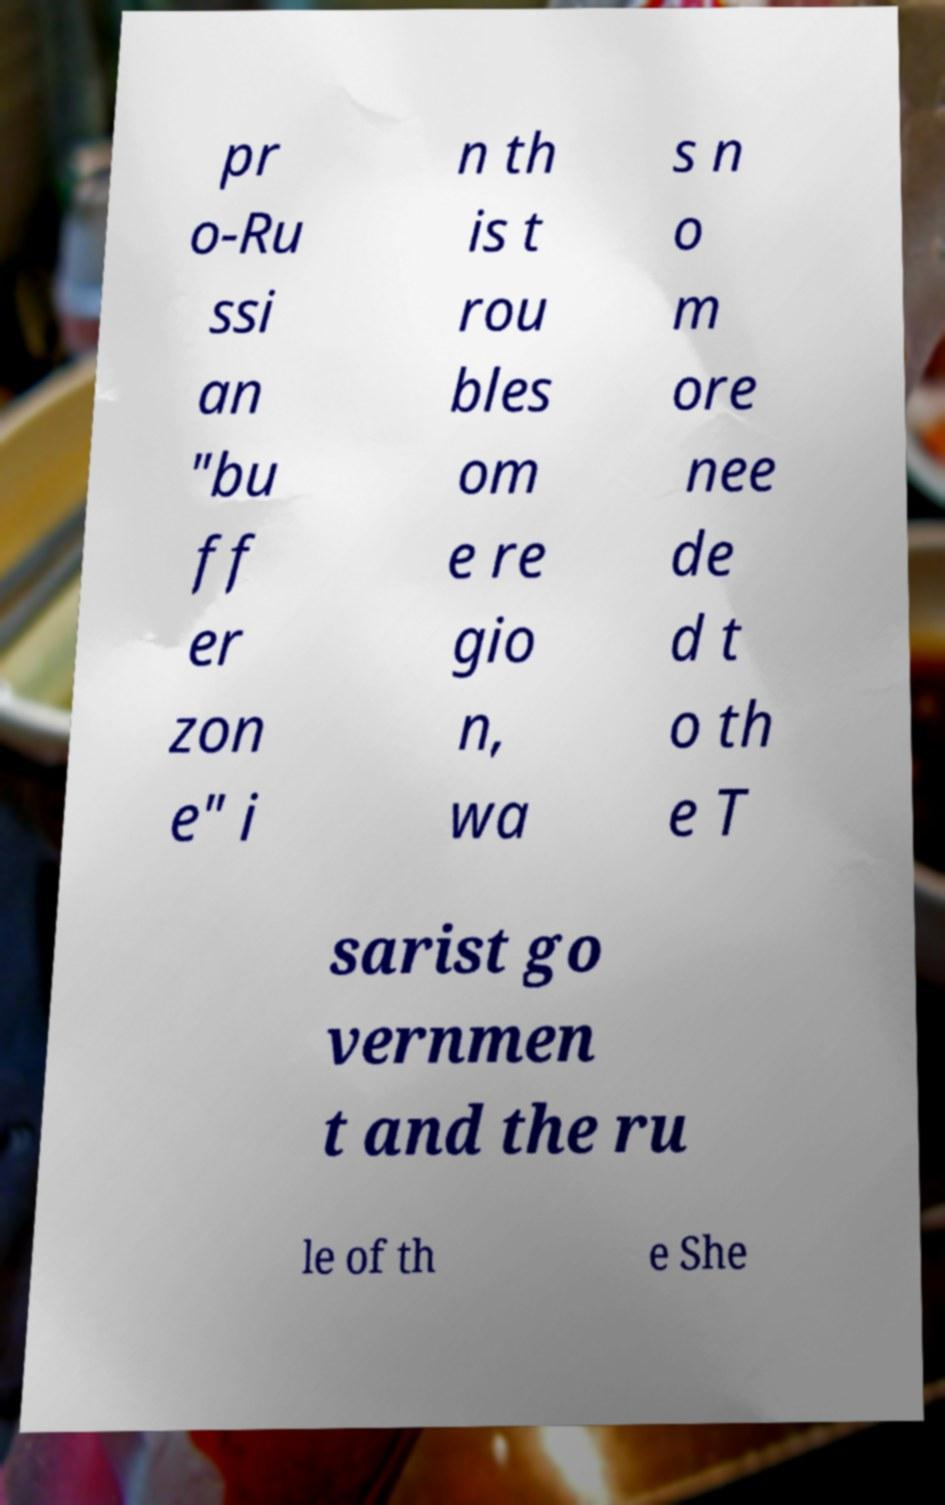Could you assist in decoding the text presented in this image and type it out clearly? pr o-Ru ssi an "bu ff er zon e" i n th is t rou bles om e re gio n, wa s n o m ore nee de d t o th e T sarist go vernmen t and the ru le of th e She 